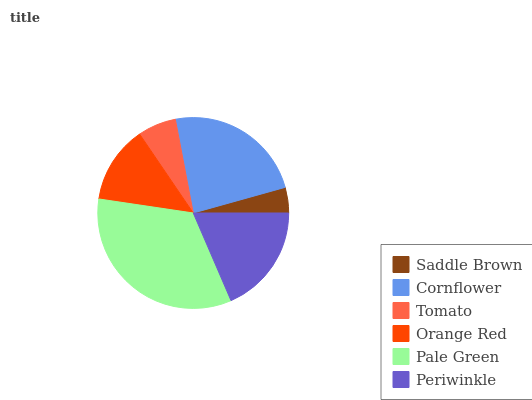Is Saddle Brown the minimum?
Answer yes or no. Yes. Is Pale Green the maximum?
Answer yes or no. Yes. Is Cornflower the minimum?
Answer yes or no. No. Is Cornflower the maximum?
Answer yes or no. No. Is Cornflower greater than Saddle Brown?
Answer yes or no. Yes. Is Saddle Brown less than Cornflower?
Answer yes or no. Yes. Is Saddle Brown greater than Cornflower?
Answer yes or no. No. Is Cornflower less than Saddle Brown?
Answer yes or no. No. Is Periwinkle the high median?
Answer yes or no. Yes. Is Orange Red the low median?
Answer yes or no. Yes. Is Cornflower the high median?
Answer yes or no. No. Is Pale Green the low median?
Answer yes or no. No. 